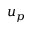<formula> <loc_0><loc_0><loc_500><loc_500>u _ { p }</formula> 